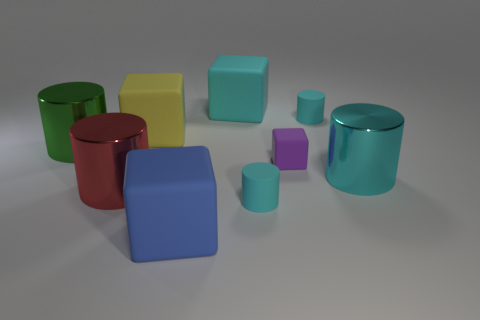Subtract all brown blocks. How many cyan cylinders are left? 3 Subtract 1 cylinders. How many cylinders are left? 4 Subtract all green cylinders. How many cylinders are left? 4 Subtract all red cylinders. How many cylinders are left? 4 Subtract all yellow cylinders. Subtract all red blocks. How many cylinders are left? 5 Subtract all blocks. How many objects are left? 5 Subtract 1 yellow blocks. How many objects are left? 8 Subtract all large yellow spheres. Subtract all small purple blocks. How many objects are left? 8 Add 4 blue cubes. How many blue cubes are left? 5 Add 8 big cyan metal cylinders. How many big cyan metal cylinders exist? 9 